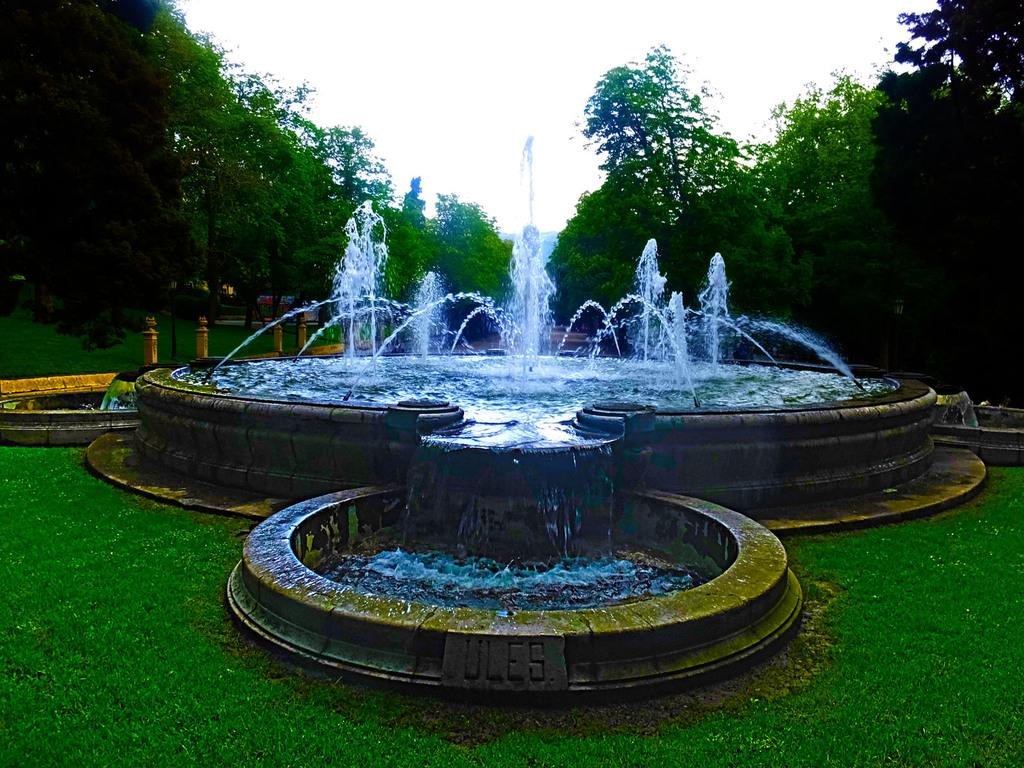What is located in the middle of the image? There are fountains in the middle of the image. What type of vegetation is on either side of the image? There are trees on either side of the image. What is visible at the top of the image? The sky is visible at the top of the image. How many times does the pipe fold in the image? There is no pipe present in the image. What time is displayed on the watch in the image? There is no watch present in the image. 